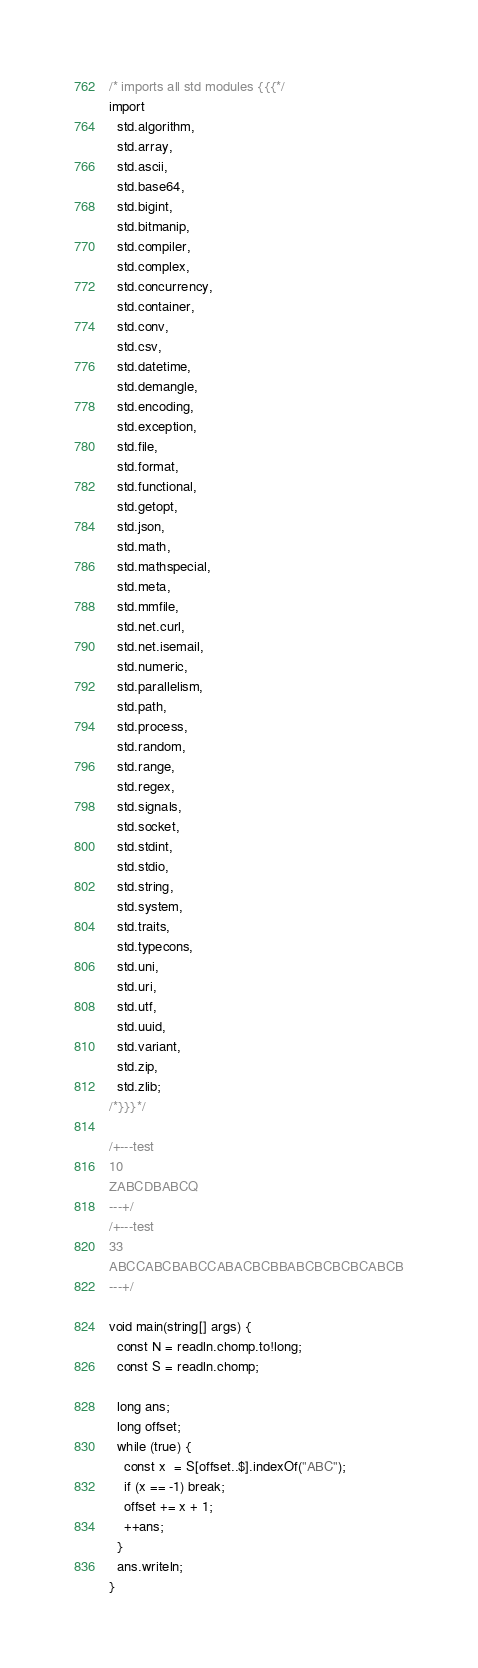<code> <loc_0><loc_0><loc_500><loc_500><_D_>/* imports all std modules {{{*/
import
  std.algorithm,
  std.array,
  std.ascii,
  std.base64,
  std.bigint,
  std.bitmanip,
  std.compiler,
  std.complex,
  std.concurrency,
  std.container,
  std.conv,
  std.csv,
  std.datetime,
  std.demangle,
  std.encoding,
  std.exception,
  std.file,
  std.format,
  std.functional,
  std.getopt,
  std.json,
  std.math,
  std.mathspecial,
  std.meta,
  std.mmfile,
  std.net.curl,
  std.net.isemail,
  std.numeric,
  std.parallelism,
  std.path,
  std.process,
  std.random,
  std.range,
  std.regex,
  std.signals,
  std.socket,
  std.stdint,
  std.stdio,
  std.string,
  std.system,
  std.traits,
  std.typecons,
  std.uni,
  std.uri,
  std.utf,
  std.uuid,
  std.variant,
  std.zip,
  std.zlib;
/*}}}*/

/+---test
10
ZABCDBABCQ
---+/
/+---test
33
ABCCABCBABCCABACBCBBABCBCBCBCABCB
---+/

void main(string[] args) {
  const N = readln.chomp.to!long;
  const S = readln.chomp;

  long ans;
  long offset;
  while (true) {
    const x  = S[offset..$].indexOf("ABC");
    if (x == -1) break;
    offset += x + 1;
    ++ans;
  }
  ans.writeln;
}
</code> 